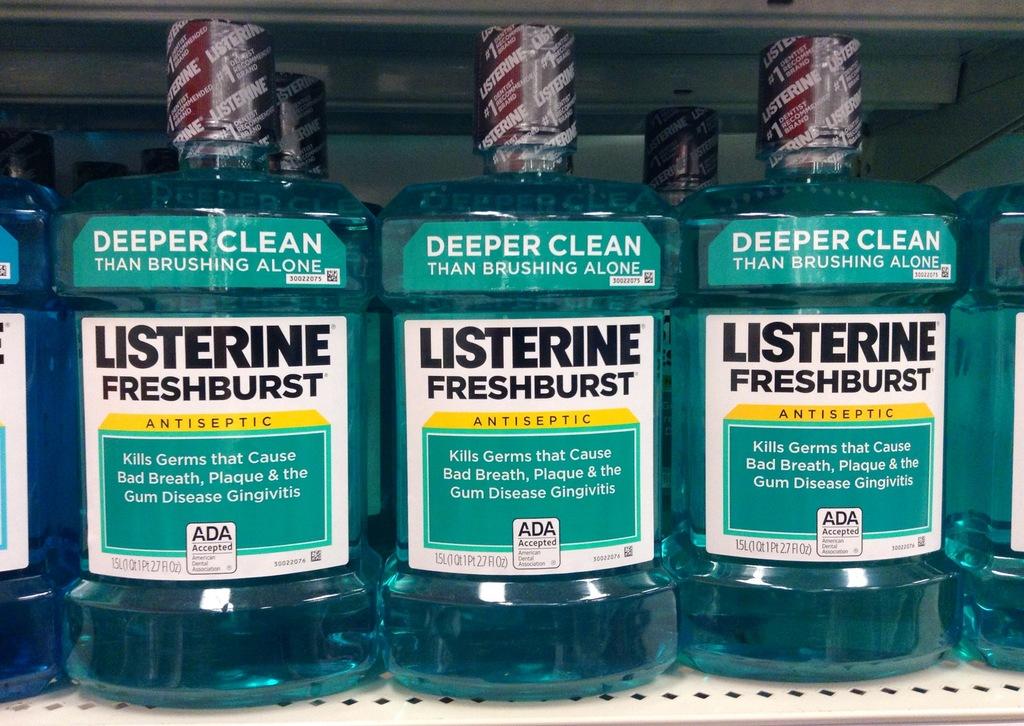What brand is this mouth wash?
Provide a short and direct response. Listerine. 